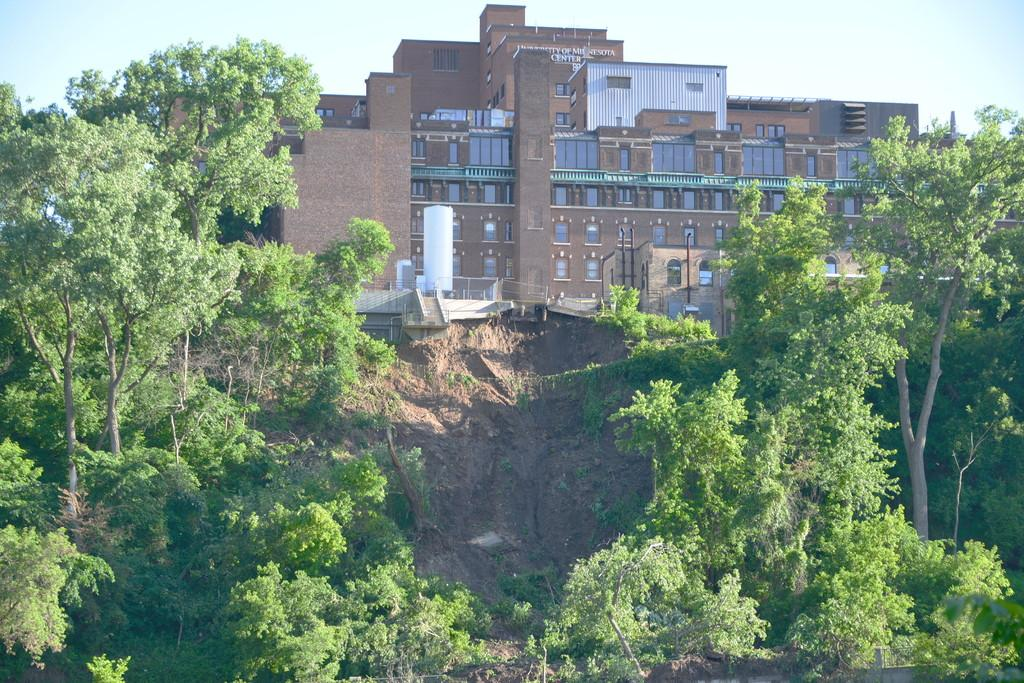What type of structures can be seen in the image? There are buildings in the image. What other objects can be seen in the image besides buildings? There are trees, poles, and tanks in the image. What is visible at the top of the image? The sky is visible at the top of the image. What type of underwear is hanging on the poles in the image? There is no underwear present in the image; it features buildings, trees, poles, and tanks. How many chickens can be seen in the image? There are no chickens present in the image. 